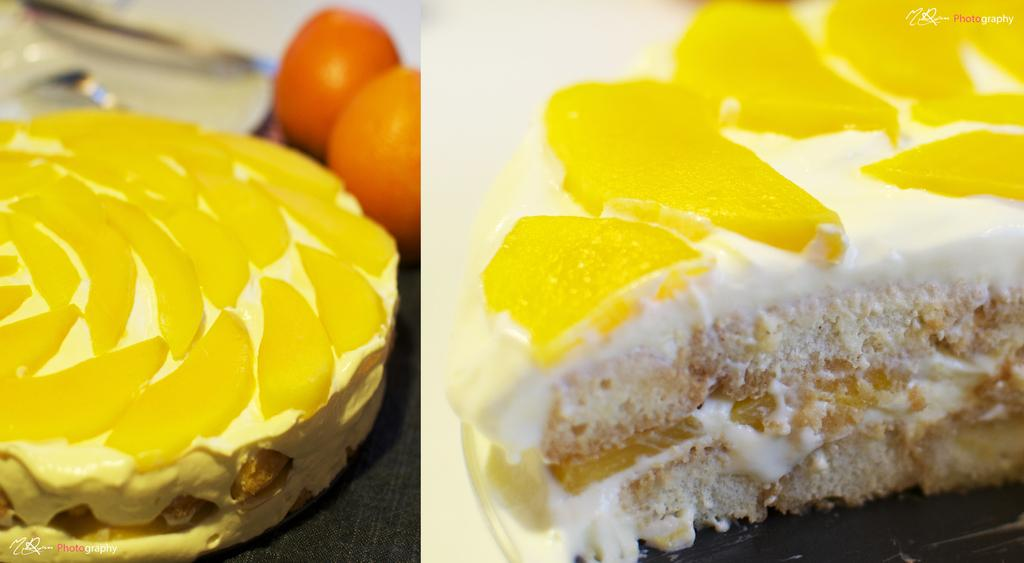What type of pastry is featured in the image? There is a pastry with fruit slices in the image. What other items can be seen on the table in the image? There are two oranges on the table in the image. What color is the pencil used to draw the yoke in the image? There is no pencil or drawing of a yoke present in the image. 